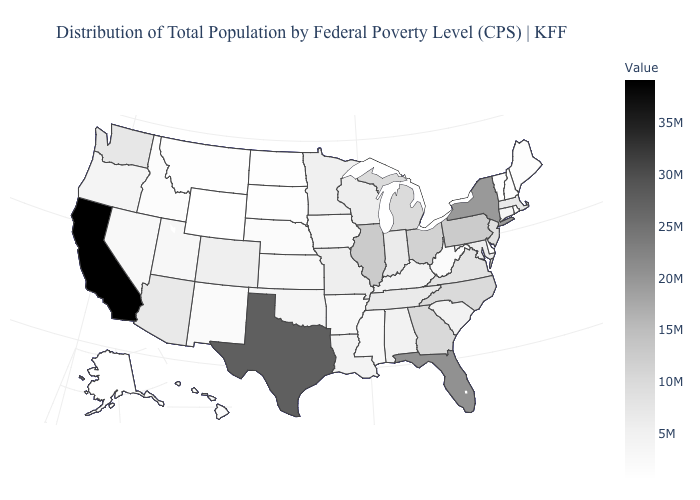Among the states that border New Hampshire , which have the lowest value?
Keep it brief. Vermont. Does the map have missing data?
Write a very short answer. No. Does the map have missing data?
Answer briefly. No. 